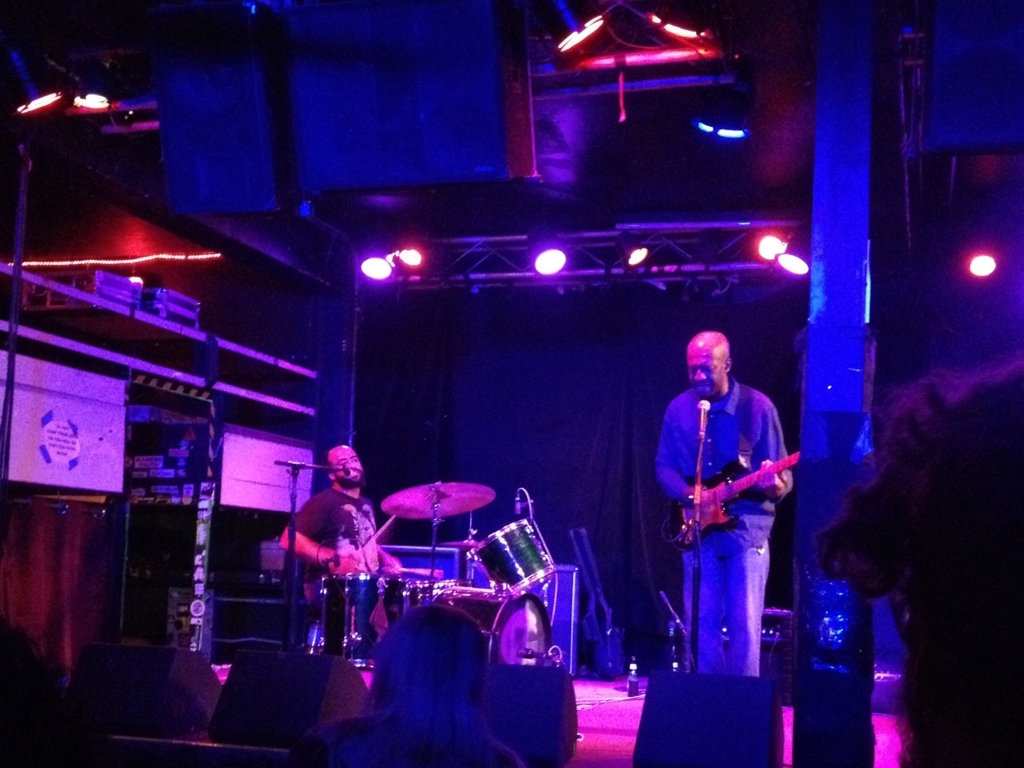What can we infer about the music genre being performed in this image? Based on the setup, with the electric guitar and visible drum kit, it suggests a genre that involves a band setup, possibly rock, blues, or indie. The informal attire of the musician and the casual ambiance hint towards a genre that is relaxed and perhaps oriented towards musical expression and improvisation. 